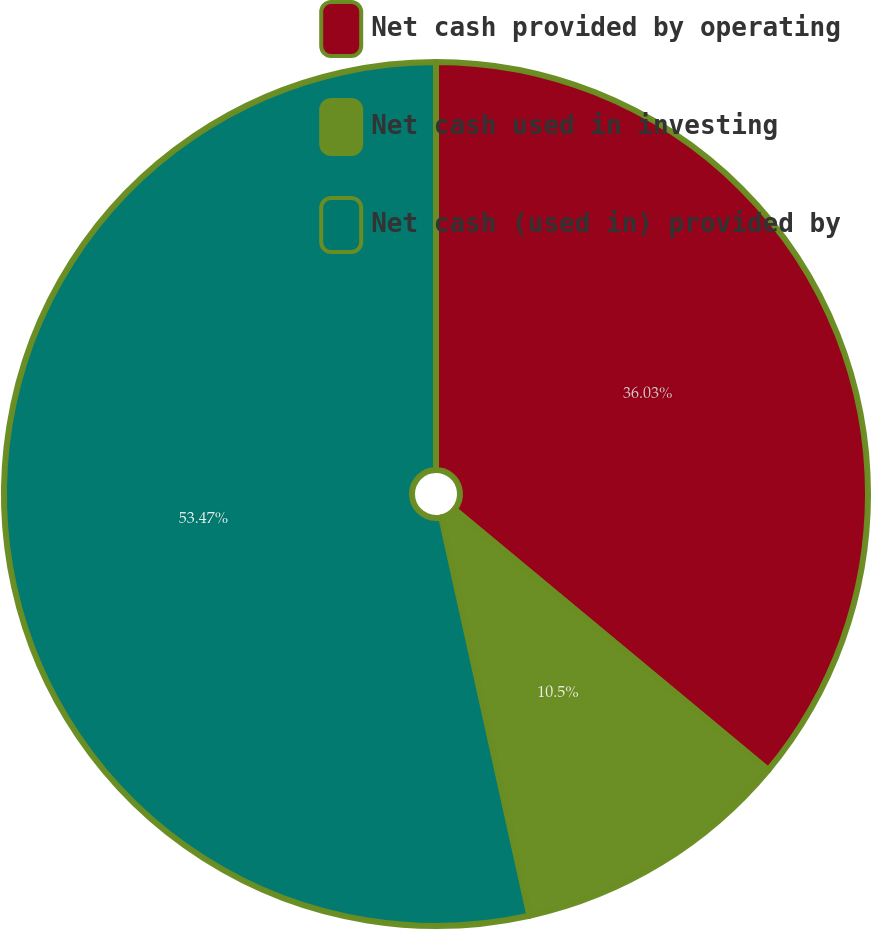<chart> <loc_0><loc_0><loc_500><loc_500><pie_chart><fcel>Net cash provided by operating<fcel>Net cash used in investing<fcel>Net cash (used in) provided by<nl><fcel>36.03%<fcel>10.5%<fcel>53.47%<nl></chart> 